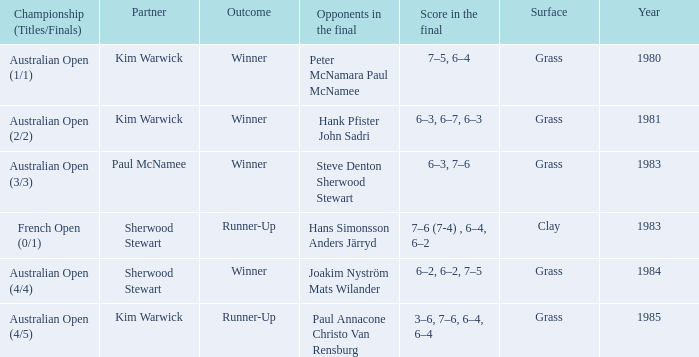Can you give me this table as a dict? {'header': ['Championship (Titles/Finals)', 'Partner', 'Outcome', 'Opponents in the final', 'Score in the final', 'Surface', 'Year'], 'rows': [['Australian Open (1/1)', 'Kim Warwick', 'Winner', 'Peter McNamara Paul McNamee', '7–5, 6–4', 'Grass', '1980'], ['Australian Open (2/2)', 'Kim Warwick', 'Winner', 'Hank Pfister John Sadri', '6–3, 6–7, 6–3', 'Grass', '1981'], ['Australian Open (3/3)', 'Paul McNamee', 'Winner', 'Steve Denton Sherwood Stewart', '6–3, 7–6', 'Grass', '1983'], ['French Open (0/1)', 'Sherwood Stewart', 'Runner-Up', 'Hans Simonsson Anders Järryd', '7–6 (7-4) , 6–4, 6–2', 'Clay', '1983'], ['Australian Open (4/4)', 'Sherwood Stewart', 'Winner', 'Joakim Nyström Mats Wilander', '6–2, 6–2, 7–5', 'Grass', '1984'], ['Australian Open (4/5)', 'Kim Warwick', 'Runner-Up', 'Paul Annacone Christo Van Rensburg', '3–6, 7–6, 6–4, 6–4', 'Grass', '1985']]} How many different partners were played with during French Open (0/1)? 1.0. 